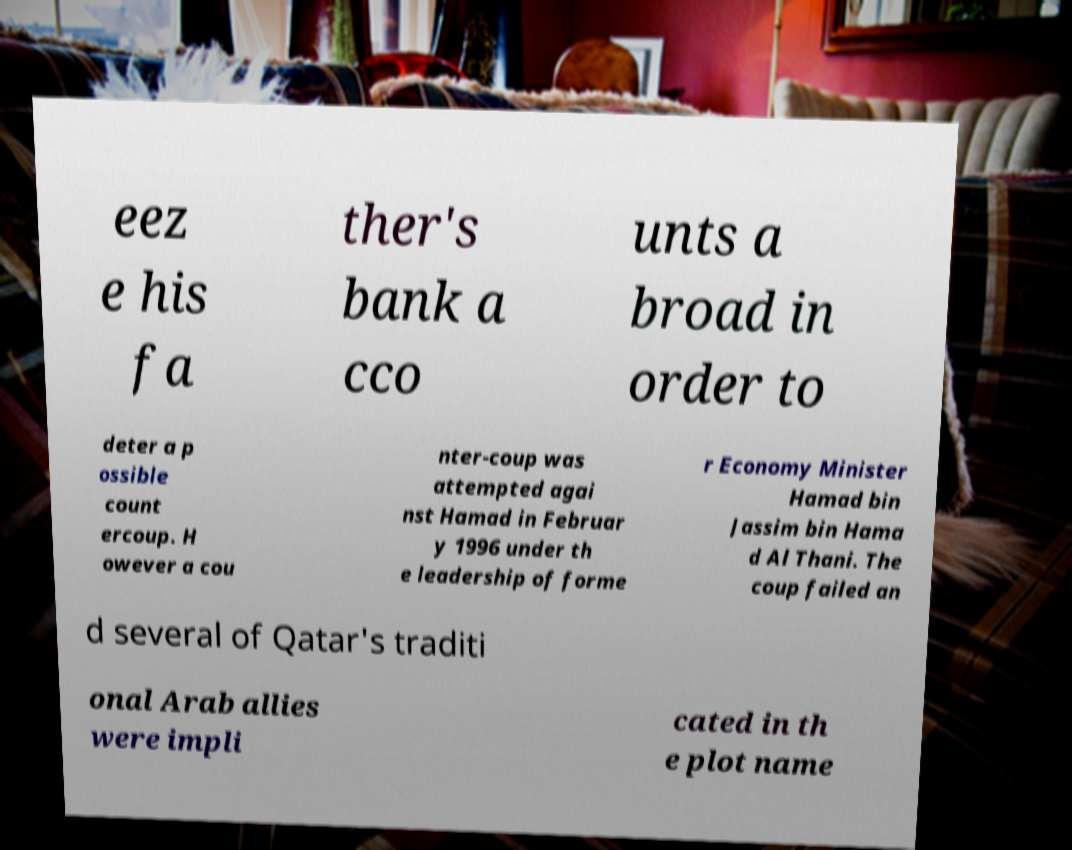For documentation purposes, I need the text within this image transcribed. Could you provide that? eez e his fa ther's bank a cco unts a broad in order to deter a p ossible count ercoup. H owever a cou nter-coup was attempted agai nst Hamad in Februar y 1996 under th e leadership of forme r Economy Minister Hamad bin Jassim bin Hama d Al Thani. The coup failed an d several of Qatar's traditi onal Arab allies were impli cated in th e plot name 